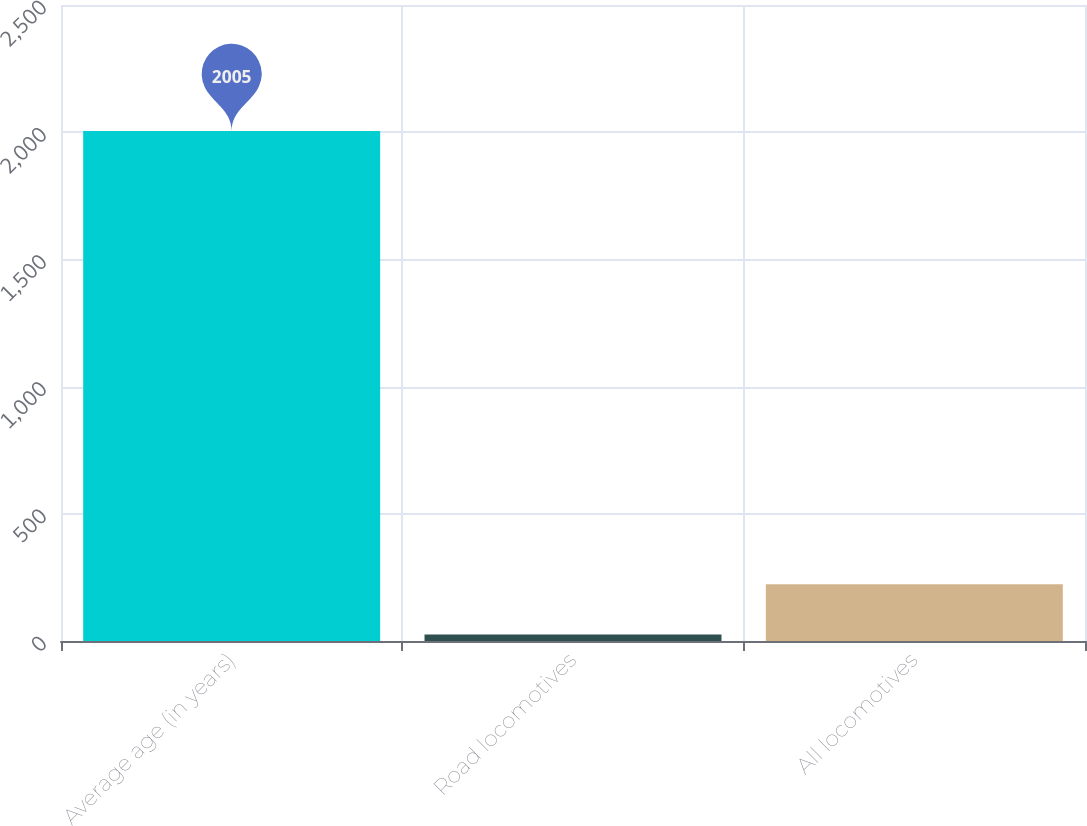Convert chart to OTSL. <chart><loc_0><loc_0><loc_500><loc_500><bar_chart><fcel>Average age (in years)<fcel>Road locomotives<fcel>All locomotives<nl><fcel>2005<fcel>25.2<fcel>223.18<nl></chart> 